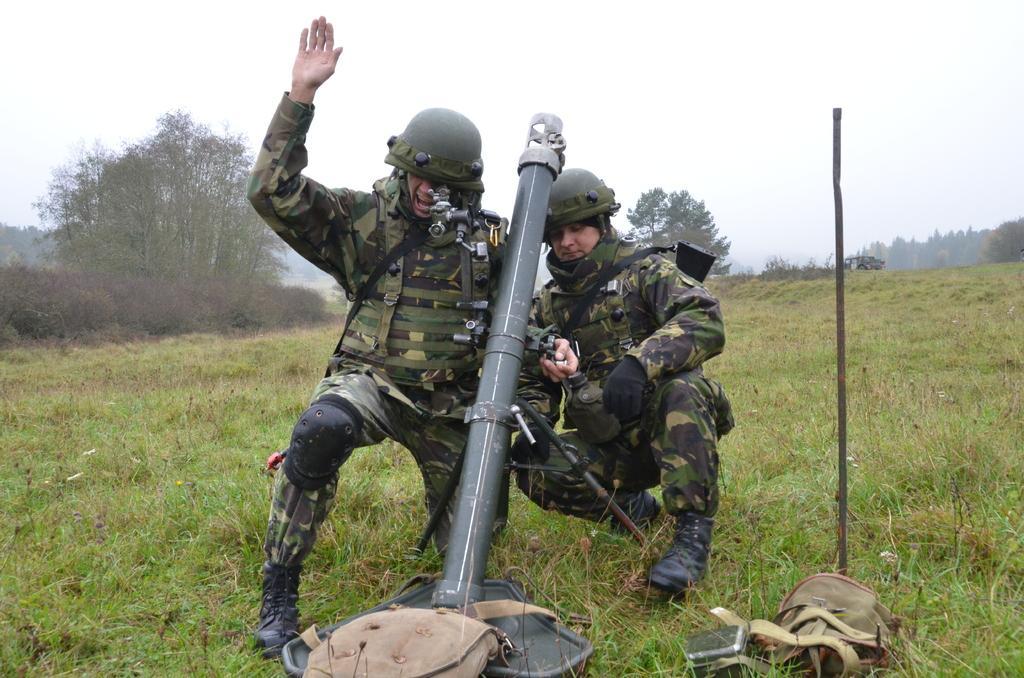How would you summarize this image in a sentence or two? In this image there are two people holding an object, which is on the surface of the grass, beside them there is a stick and a few other objects. In the background there are trees and the sky. 